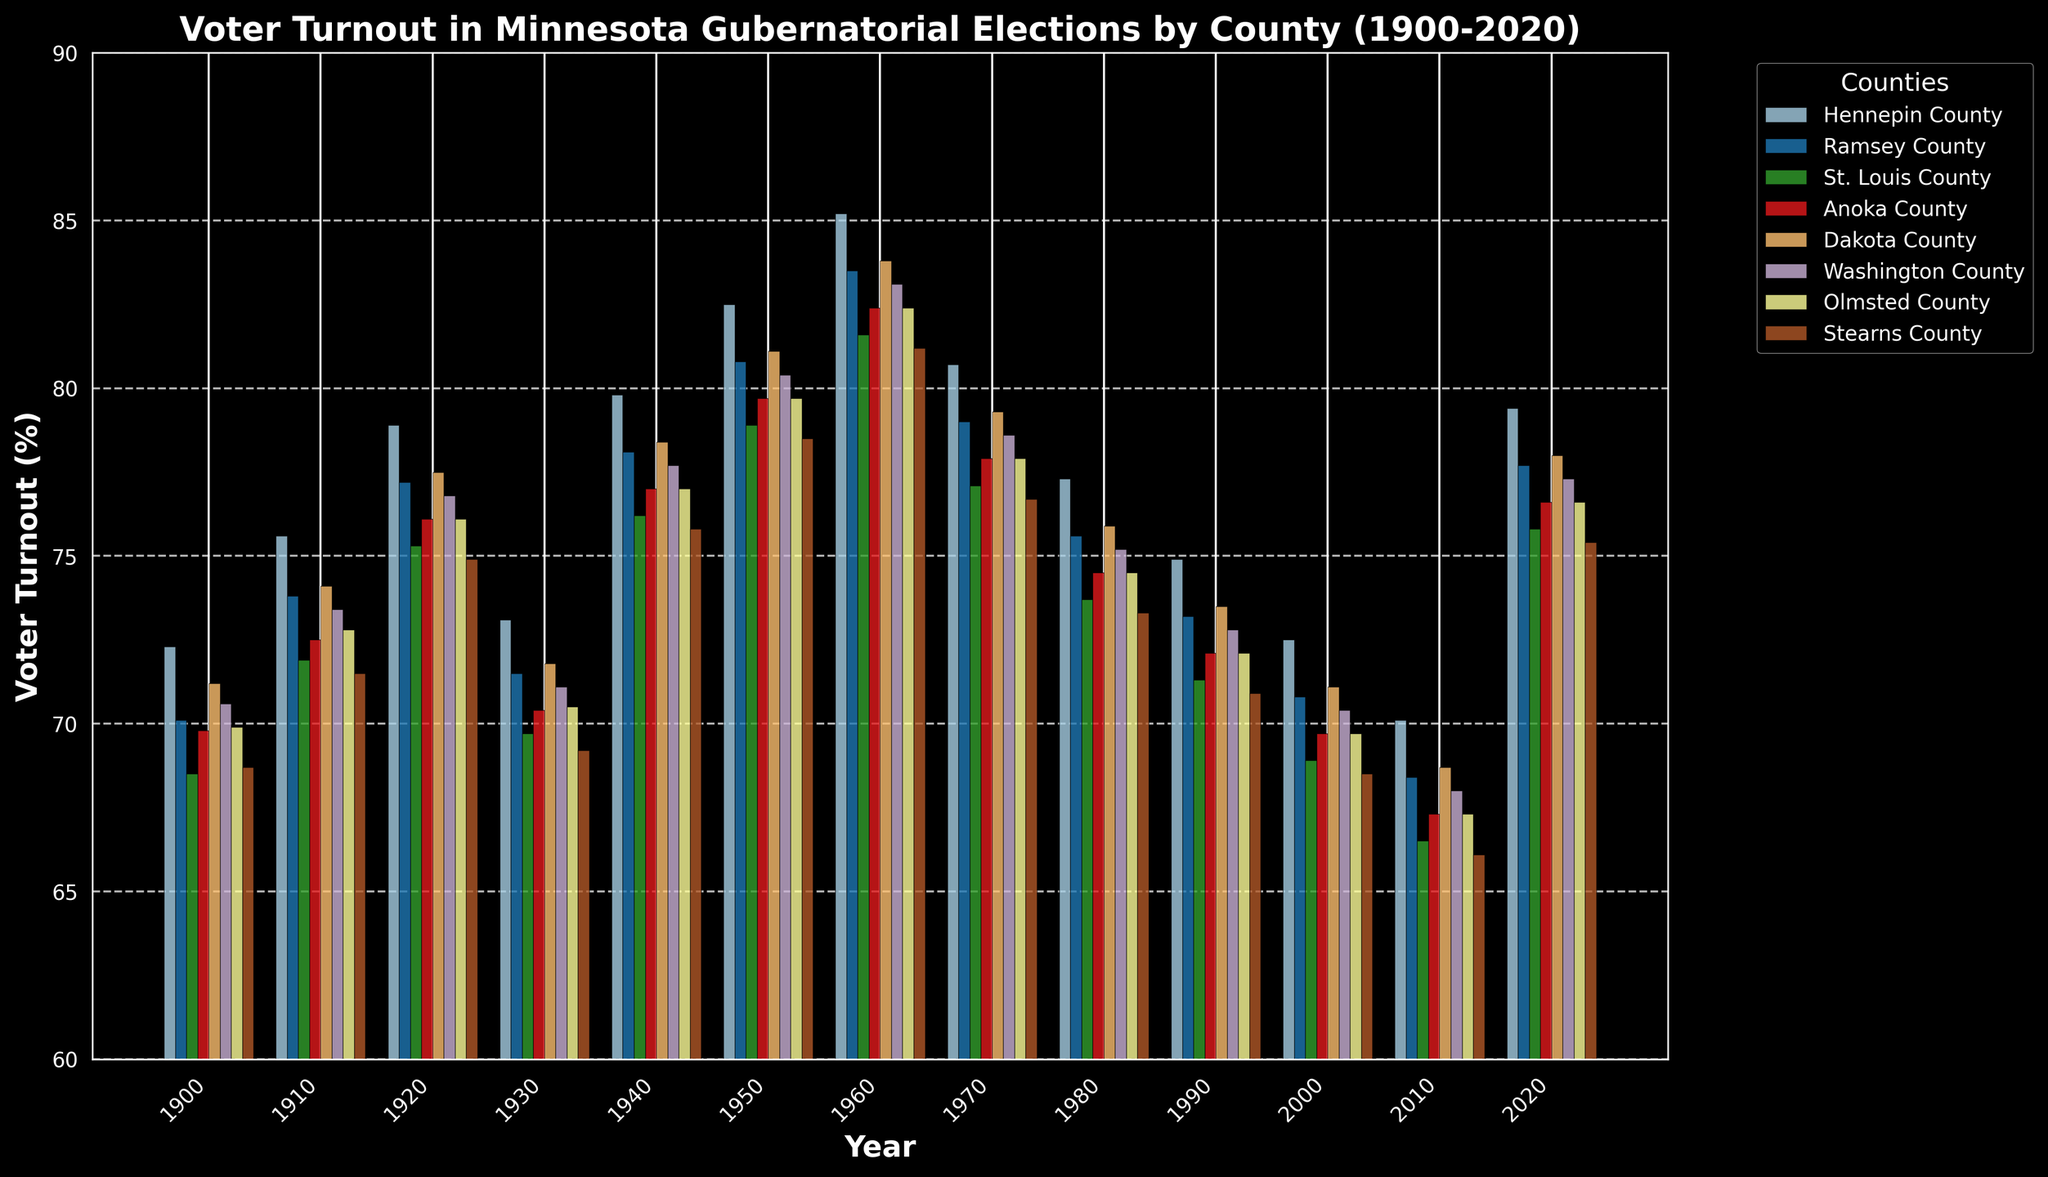Which county had the highest voter turnout in 1940? The highest bar in 1940 corresponds to the county with the largest value. From the chart, Hennepin County has the highest turnout.
Answer: Hennepin County How did voter turnout in Hennepin County in 1930 compare to 2020? First, identify the bars for Hennepin County in 1930 and 2020. Compare the heights: turnout in 1930 is 73.1%, and in 2020, it is 79.4%, showing an increase.
Answer: Increase Which two counties had voter turnouts closest to each other in 1910? Check the 1910 bars and identify pairs with similar heights. Ramsey County (73.8%) and Washington County (73.4%) are closest.
Answer: Ramsey and Washington counties For Dakota County, what is the difference in voter turnout between 2000 and 2020? Find Dakota County's voter turnout in 2000 (71.1%) and in 2020 (78.0%). Subtract the former from the latter: 78.0% - 71.1% = 6.9%.
Answer: 6.9% What is the average voter turnout across all counties in 1970? Sum the voter turnouts for all counties in 1970 and divide by the number of counties: (80.7 + 79.0 + 77.1 + 77.9 + 79.3 + 78.6 + 77.9 + 76.7) / 8 = 78.15%.
Answer: 78.15% Which county had the most significant decrease in voter turnout from 1960 to 1980? Compare the turnout differences for each county from 1960 to 1980. St. Louis County has the largest drop: from 81.6% to 73.7%.
Answer: St. Louis County Was the voter turnout in Olmsted County always above 67%? Check if any bar for Olmsted County falls below 67%. All bars are above 67%, so the voter turnout was always above this threshold.
Answer: Yes 